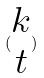<formula> <loc_0><loc_0><loc_500><loc_500>( \begin{matrix} k \\ t \end{matrix} )</formula> 